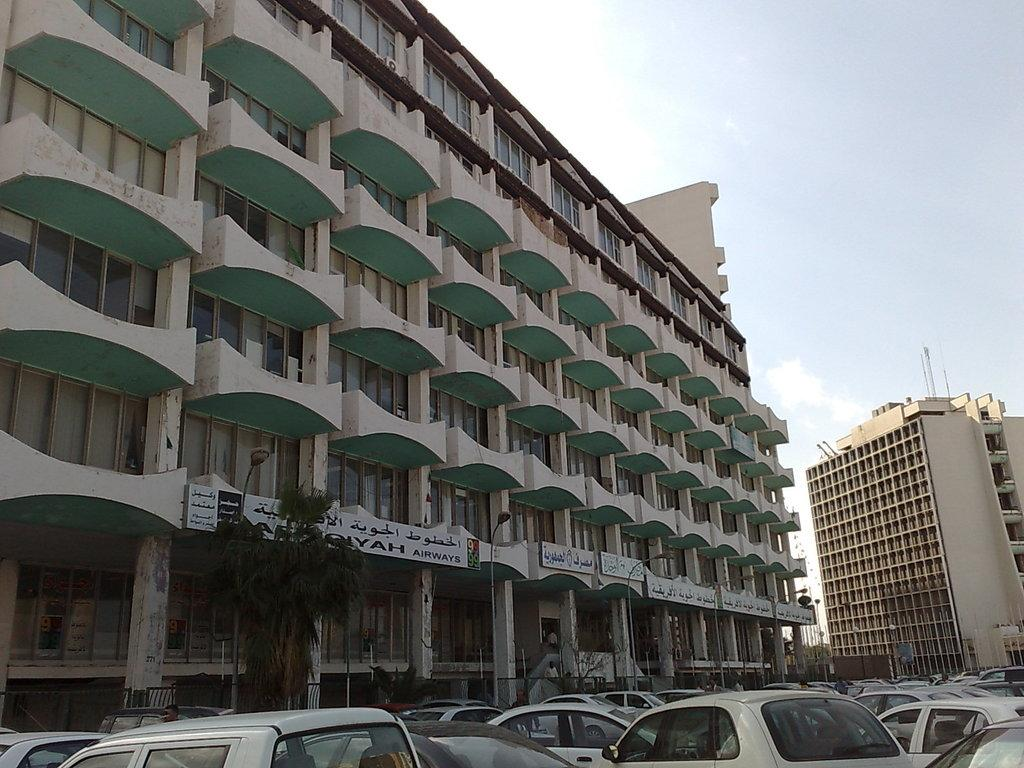What is located in the center of the image? There are buildings in the center of the image. What type of vegetation can be seen in the image? There are trees in the image. What architectural features are present in the image? There are pillars in the image. What is visible at the bottom of the image? There are vehicles at the bottom of the image. What is visible at the top of the image? The sky is visible at the top of the image. How does the decision affect the root in the image? There is no decision or root present in the image. Can you describe the sneeze of the person in the image? There is no person sneezing in the image; it features buildings, trees, pillars, vehicles, and the sky. 